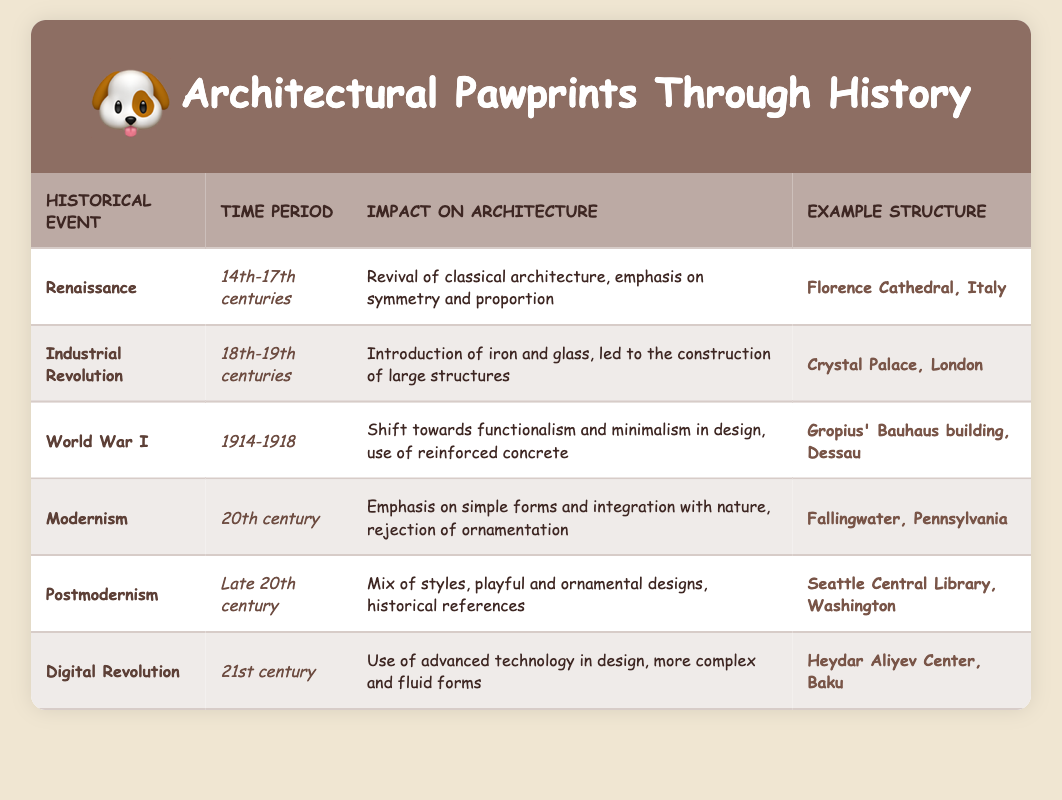What architectural style was emphasized during the Renaissance? The table specifies that the Renaissance is characterized by a "Revival of classical architecture, emphasis on symmetry and proportion," which indicates its architectural style.
Answer: Classical architecture Which historical event corresponds with the structure known as the Crystal Palace? From the table, the corresponding historical event for the Crystal Palace is the Industrial Revolution, which occurred in the 18th-19th centuries.
Answer: Industrial Revolution Did World War I have an impact on architectural designs? Yes, the table confirms that World War I influenced architecture, stating there was a "shift towards functionalism and minimalism in design, use of reinforced concrete."
Answer: Yes What is the main impact of Modernism on architectural design? According to the information in the table, Modernism emphasized "simple forms and integration with nature, rejection of ornamentation." This highlights its main impact on design.
Answer: Simple forms and integration with nature Which two architectural events were characterized by a shift towards new materials and technology? The Industrial Revolution brought the "introduction of iron and glass," while the Digital Revolution led to the "use of advanced technology in design." Both indicate changes in materials and technology.
Answer: Industrial Revolution and Digital Revolution How many events mentioned in the table occurred in the 20th century? The table lists four events: World War I, Modernism, Postmodernism, and the Digital Revolution all in relation to the 20th century. Therefore, the count of events that occurred in the 20th century is four.
Answer: Four events Was the impact of Postmodernism limited to historical references? No, the table states that Postmodernism involved a "mix of styles, playful and ornamental designs," meaning its impact was broader than just historical references.
Answer: No What architectural structure represents the impact of the Digital Revolution? The Heydar Aliyev Center in Baku is mentioned in the table as an example structure illustrating the impact of the Digital Revolution.
Answer: Heydar Aliyev Center, Baku What does the table reveal about the relationship between historical events and architectural designs? The table shows that each historical event significantly influenced architectural styles, materials, and designs, indicating a dynamic relationship throughout history.
Answer: Significant influence 